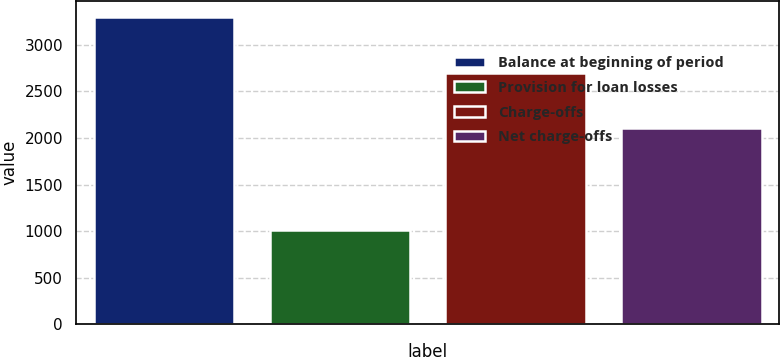<chart> <loc_0><loc_0><loc_500><loc_500><bar_chart><fcel>Balance at beginning of period<fcel>Provision for loan losses<fcel>Charge-offs<fcel>Net charge-offs<nl><fcel>3304<fcel>1013<fcel>2693<fcel>2112<nl></chart> 